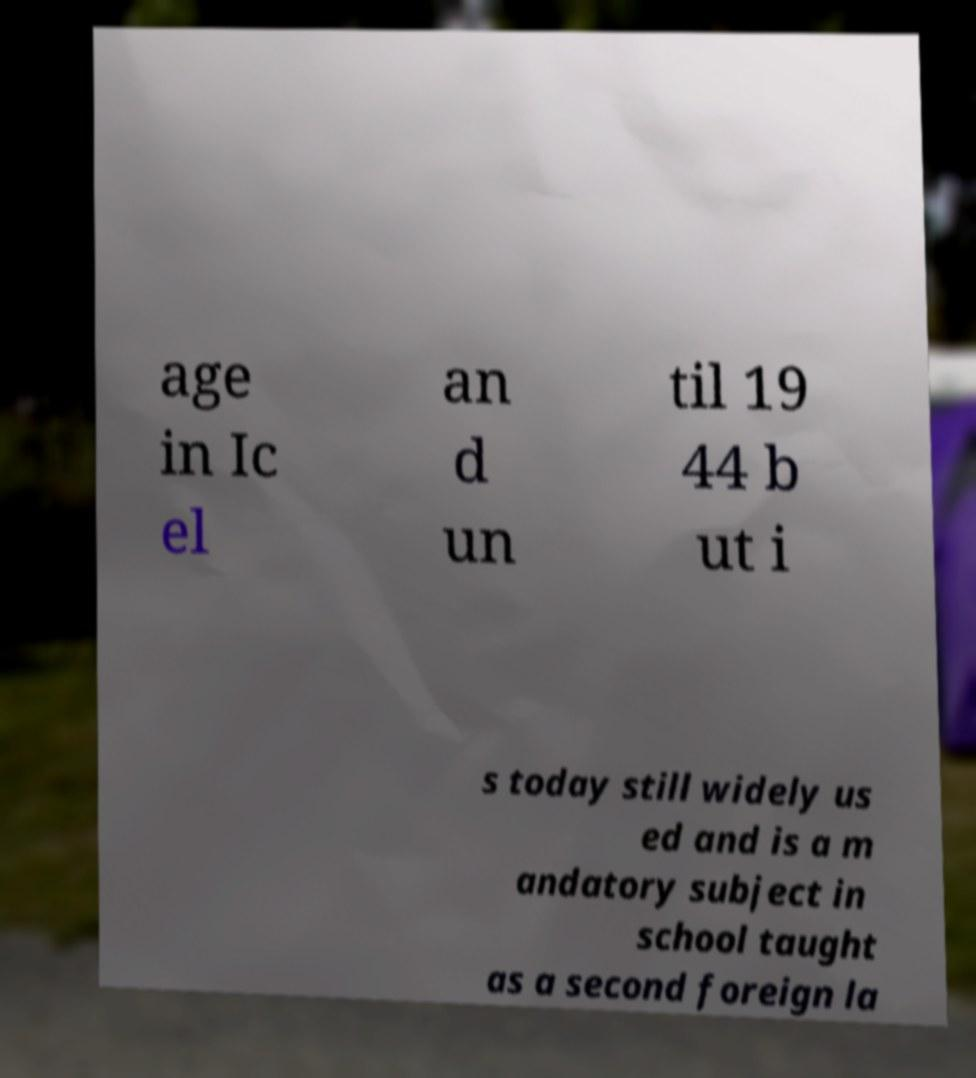Can you accurately transcribe the text from the provided image for me? age in Ic el an d un til 19 44 b ut i s today still widely us ed and is a m andatory subject in school taught as a second foreign la 